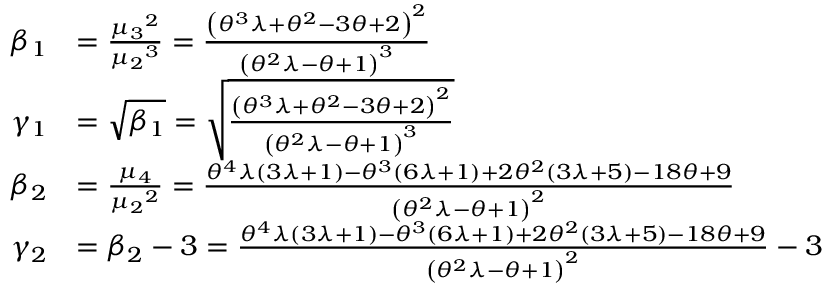<formula> <loc_0><loc_0><loc_500><loc_500>\begin{array} { r l } { \beta _ { 1 } } & { = \frac { { \mu _ { 3 } } ^ { 2 } } { { \mu _ { 2 } } ^ { 3 } } = \frac { \left ( \theta ^ { 3 } \lambda + \theta ^ { 2 } - 3 \theta + 2 \right ) ^ { 2 } } { \left ( \theta ^ { 2 } \lambda - \theta + 1 \right ) ^ { 3 } } } \\ { \gamma _ { 1 } } & { = \sqrt { \beta _ { 1 } } = \sqrt { \frac { \left ( \theta ^ { 3 } \lambda + \theta ^ { 2 } - 3 \theta + 2 \right ) ^ { 2 } } { \left ( \theta ^ { 2 } \lambda - \theta + 1 \right ) ^ { 3 } } } } \\ { \beta _ { 2 } } & { = \frac { \mu _ { 4 } } { { \mu _ { 2 } } ^ { 2 } } = \frac { \theta ^ { 4 } \lambda ( 3 \lambda + 1 ) - \theta ^ { 3 } ( 6 \lambda + 1 ) + 2 \theta ^ { 2 } ( 3 \lambda + 5 ) - 1 8 \theta + 9 } { \left ( \theta ^ { 2 } \lambda - \theta + 1 \right ) ^ { 2 } } } \\ { \gamma _ { 2 } } & { = \beta _ { 2 } - 3 = \frac { \theta ^ { 4 } \lambda ( 3 \lambda + 1 ) - \theta ^ { 3 } ( 6 \lambda + 1 ) + 2 \theta ^ { 2 } ( 3 \lambda + 5 ) - 1 8 \theta + 9 } { \left ( \theta ^ { 2 } \lambda - \theta + 1 \right ) ^ { 2 } } - 3 } \end{array}</formula> 